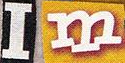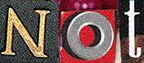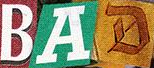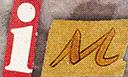Transcribe the words shown in these images in order, separated by a semicolon. Im; Not; BAD; iM 